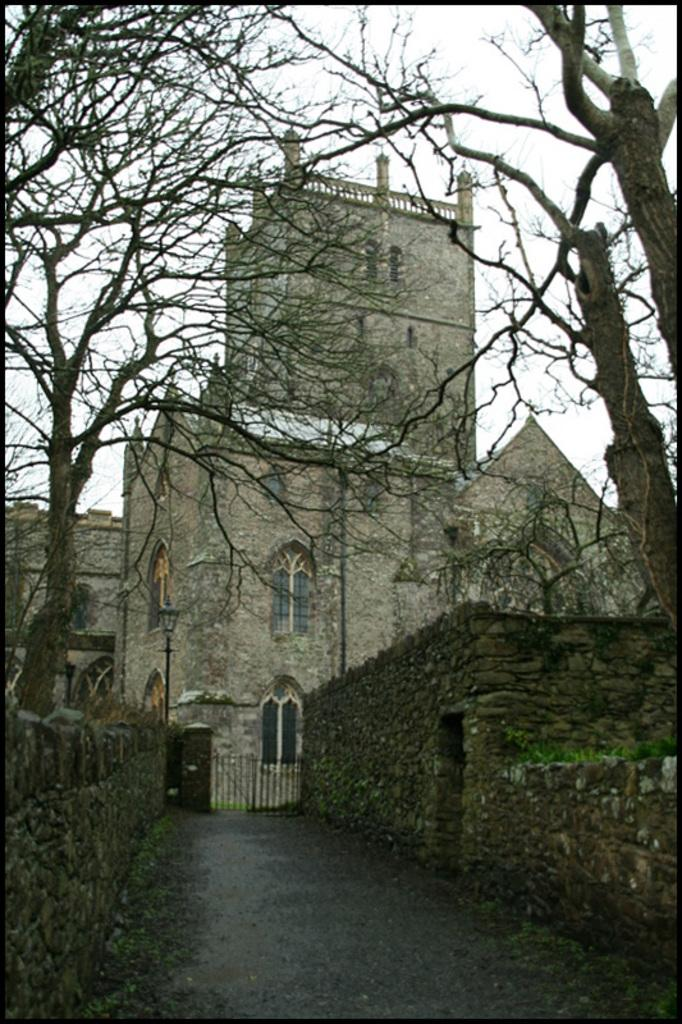What type of vegetation can be seen in the image? There are many dried trees in the image. What structure is visible in the background of the image? There is a fort in the background of the image. What architectural feature can be seen on the fort? There are windows in the fort. What is the color of the sky in the background of the image? The sky is white in color in the background of the image. What type of rake is being used to fold the smell in the image? There is no rake, folding, or smell present in the image. 